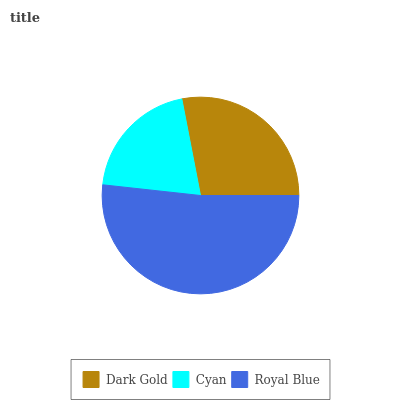Is Cyan the minimum?
Answer yes or no. Yes. Is Royal Blue the maximum?
Answer yes or no. Yes. Is Royal Blue the minimum?
Answer yes or no. No. Is Cyan the maximum?
Answer yes or no. No. Is Royal Blue greater than Cyan?
Answer yes or no. Yes. Is Cyan less than Royal Blue?
Answer yes or no. Yes. Is Cyan greater than Royal Blue?
Answer yes or no. No. Is Royal Blue less than Cyan?
Answer yes or no. No. Is Dark Gold the high median?
Answer yes or no. Yes. Is Dark Gold the low median?
Answer yes or no. Yes. Is Cyan the high median?
Answer yes or no. No. Is Royal Blue the low median?
Answer yes or no. No. 